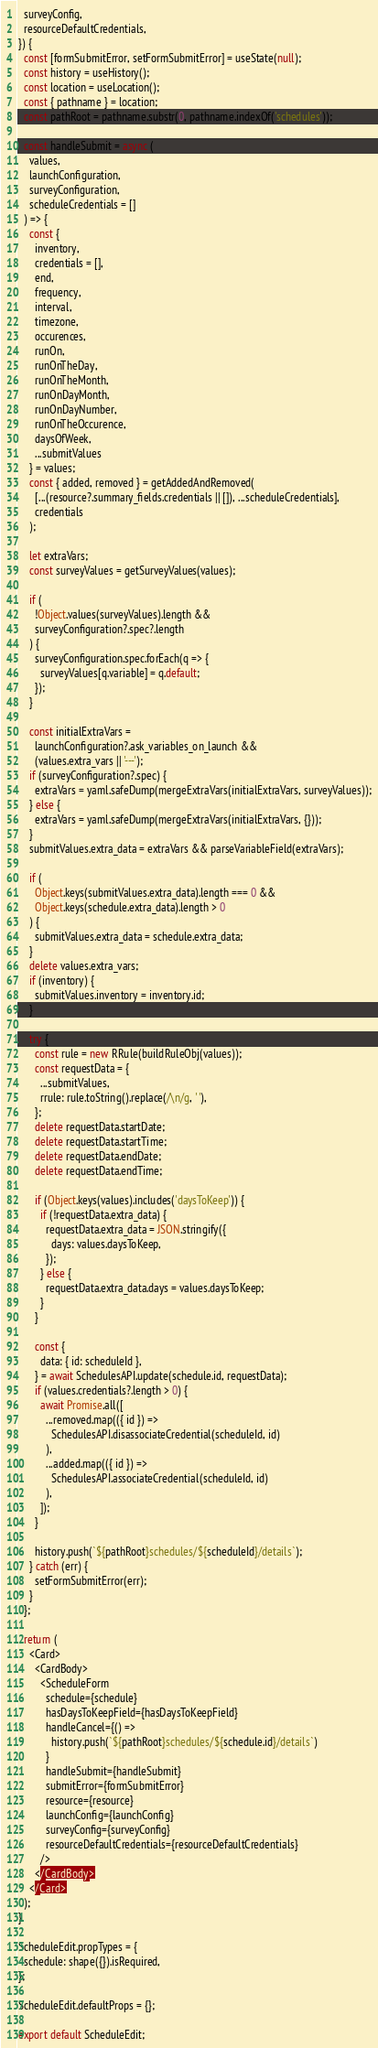Convert code to text. <code><loc_0><loc_0><loc_500><loc_500><_JavaScript_>  surveyConfig,
  resourceDefaultCredentials,
}) {
  const [formSubmitError, setFormSubmitError] = useState(null);
  const history = useHistory();
  const location = useLocation();
  const { pathname } = location;
  const pathRoot = pathname.substr(0, pathname.indexOf('schedules'));

  const handleSubmit = async (
    values,
    launchConfiguration,
    surveyConfiguration,
    scheduleCredentials = []
  ) => {
    const {
      inventory,
      credentials = [],
      end,
      frequency,
      interval,
      timezone,
      occurences,
      runOn,
      runOnTheDay,
      runOnTheMonth,
      runOnDayMonth,
      runOnDayNumber,
      runOnTheOccurence,
      daysOfWeek,
      ...submitValues
    } = values;
    const { added, removed } = getAddedAndRemoved(
      [...(resource?.summary_fields.credentials || []), ...scheduleCredentials],
      credentials
    );

    let extraVars;
    const surveyValues = getSurveyValues(values);

    if (
      !Object.values(surveyValues).length &&
      surveyConfiguration?.spec?.length
    ) {
      surveyConfiguration.spec.forEach(q => {
        surveyValues[q.variable] = q.default;
      });
    }

    const initialExtraVars =
      launchConfiguration?.ask_variables_on_launch &&
      (values.extra_vars || '---');
    if (surveyConfiguration?.spec) {
      extraVars = yaml.safeDump(mergeExtraVars(initialExtraVars, surveyValues));
    } else {
      extraVars = yaml.safeDump(mergeExtraVars(initialExtraVars, {}));
    }
    submitValues.extra_data = extraVars && parseVariableField(extraVars);

    if (
      Object.keys(submitValues.extra_data).length === 0 &&
      Object.keys(schedule.extra_data).length > 0
    ) {
      submitValues.extra_data = schedule.extra_data;
    }
    delete values.extra_vars;
    if (inventory) {
      submitValues.inventory = inventory.id;
    }

    try {
      const rule = new RRule(buildRuleObj(values));
      const requestData = {
        ...submitValues,
        rrule: rule.toString().replace(/\n/g, ' '),
      };
      delete requestData.startDate;
      delete requestData.startTime;
      delete requestData.endDate;
      delete requestData.endTime;

      if (Object.keys(values).includes('daysToKeep')) {
        if (!requestData.extra_data) {
          requestData.extra_data = JSON.stringify({
            days: values.daysToKeep,
          });
        } else {
          requestData.extra_data.days = values.daysToKeep;
        }
      }

      const {
        data: { id: scheduleId },
      } = await SchedulesAPI.update(schedule.id, requestData);
      if (values.credentials?.length > 0) {
        await Promise.all([
          ...removed.map(({ id }) =>
            SchedulesAPI.disassociateCredential(scheduleId, id)
          ),
          ...added.map(({ id }) =>
            SchedulesAPI.associateCredential(scheduleId, id)
          ),
        ]);
      }

      history.push(`${pathRoot}schedules/${scheduleId}/details`);
    } catch (err) {
      setFormSubmitError(err);
    }
  };

  return (
    <Card>
      <CardBody>
        <ScheduleForm
          schedule={schedule}
          hasDaysToKeepField={hasDaysToKeepField}
          handleCancel={() =>
            history.push(`${pathRoot}schedules/${schedule.id}/details`)
          }
          handleSubmit={handleSubmit}
          submitError={formSubmitError}
          resource={resource}
          launchConfig={launchConfig}
          surveyConfig={surveyConfig}
          resourceDefaultCredentials={resourceDefaultCredentials}
        />
      </CardBody>
    </Card>
  );
}

ScheduleEdit.propTypes = {
  schedule: shape({}).isRequired,
};

ScheduleEdit.defaultProps = {};

export default ScheduleEdit;
</code> 